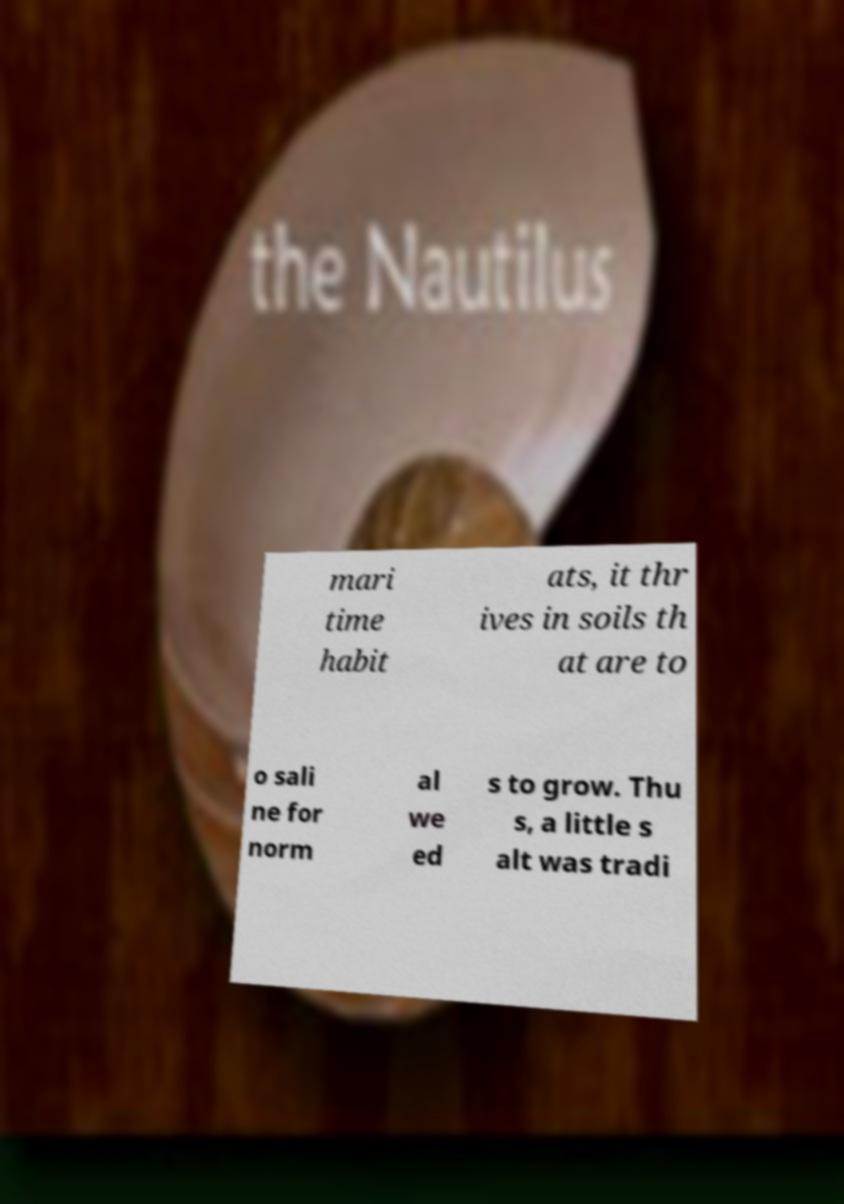Could you assist in decoding the text presented in this image and type it out clearly? mari time habit ats, it thr ives in soils th at are to o sali ne for norm al we ed s to grow. Thu s, a little s alt was tradi 